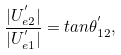Convert formula to latex. <formula><loc_0><loc_0><loc_500><loc_500>\frac { | U _ { e 2 } ^ { ^ { \prime } } | } { | U _ { e 1 } ^ { ^ { \prime } } | } = t a n \theta _ { 1 2 } ^ { ^ { \prime } } ,</formula> 